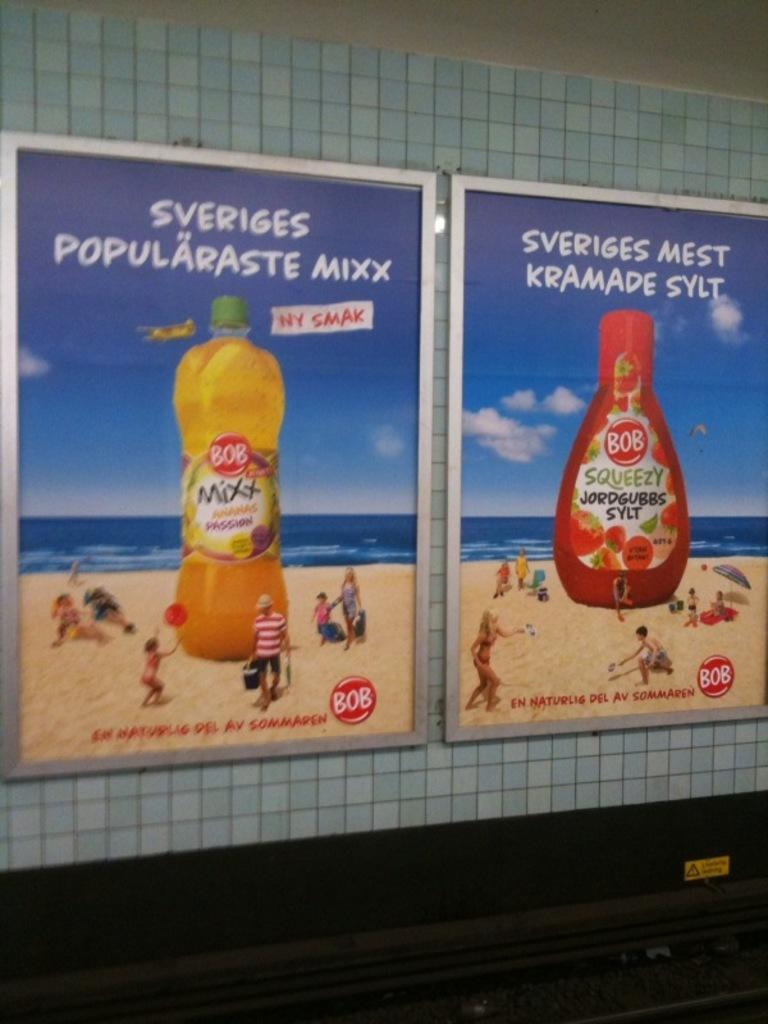<image>
Describe the image concisely. posters on a wall with one that says 'sveriges mest krmade sylt' 